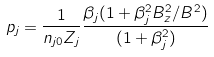Convert formula to latex. <formula><loc_0><loc_0><loc_500><loc_500>p _ { j } = \frac { 1 } { n _ { j 0 } Z _ { j } } \frac { \beta _ { j } ( 1 + \beta _ { j } ^ { 2 } B _ { z } ^ { 2 } / B ^ { 2 } ) } { ( 1 + \beta _ { j } ^ { 2 } ) }</formula> 